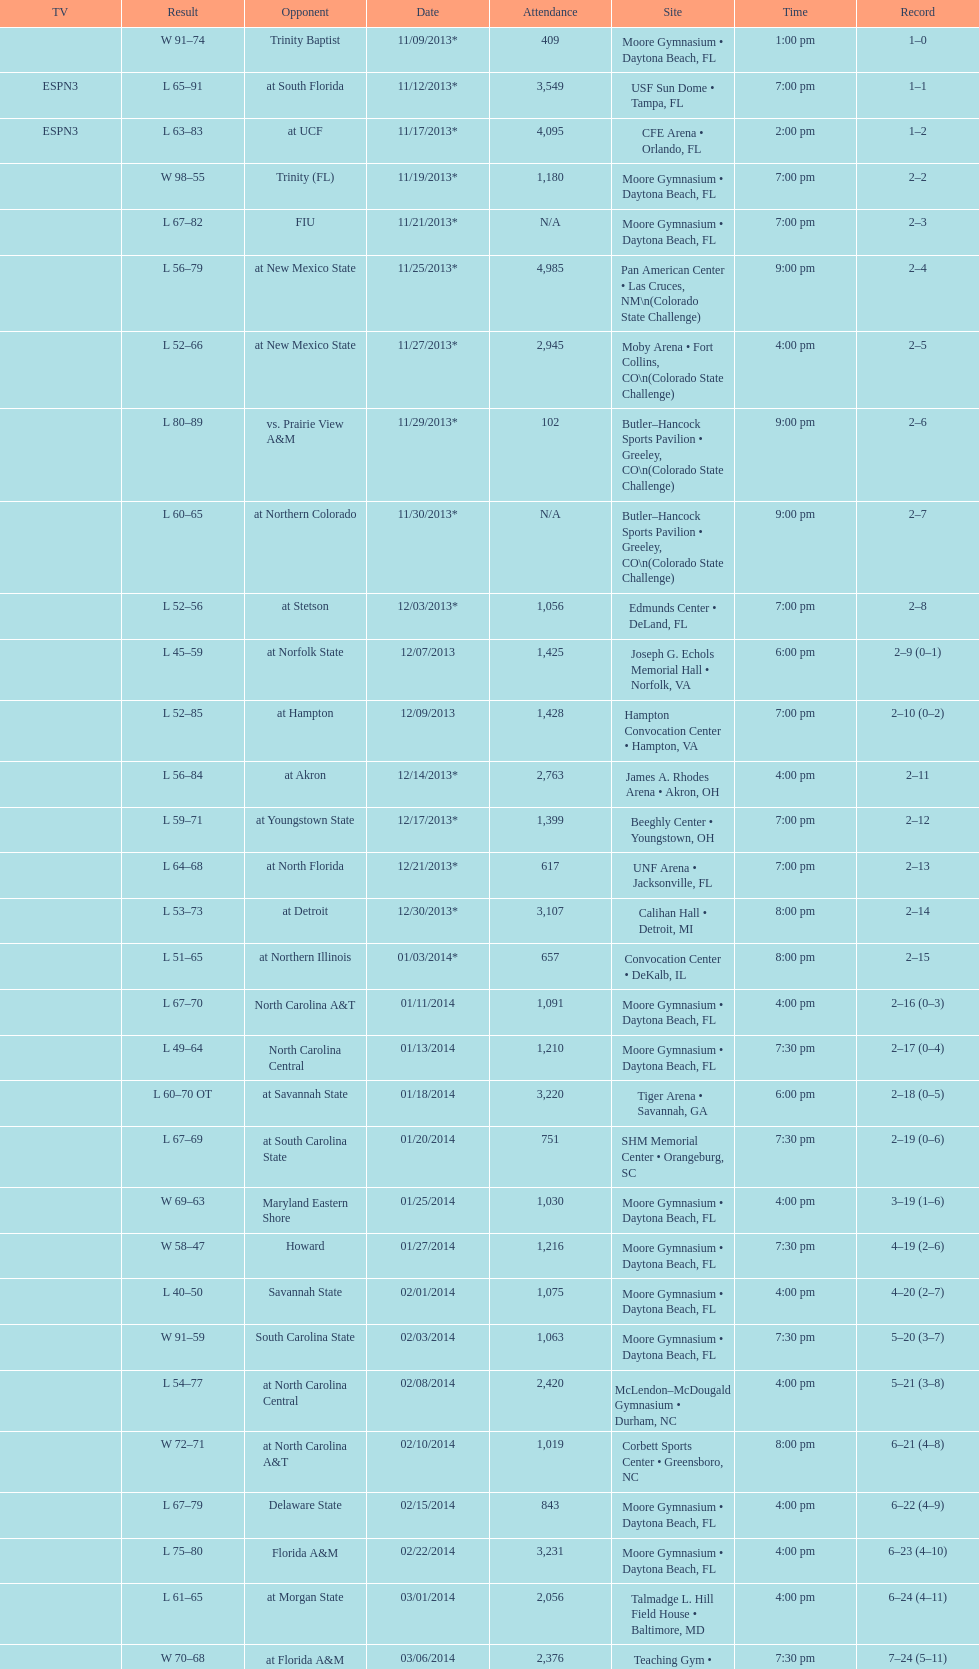Did the 11/19/2013 game attract more than 1,000 attendees? Yes. 